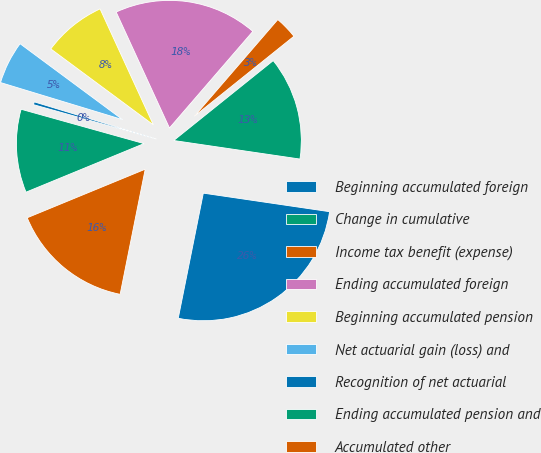<chart> <loc_0><loc_0><loc_500><loc_500><pie_chart><fcel>Beginning accumulated foreign<fcel>Change in cumulative<fcel>Income tax benefit (expense)<fcel>Ending accumulated foreign<fcel>Beginning accumulated pension<fcel>Net actuarial gain (loss) and<fcel>Recognition of net actuarial<fcel>Ending accumulated pension and<fcel>Accumulated other<nl><fcel>25.83%<fcel>13.09%<fcel>2.9%<fcel>18.19%<fcel>8.0%<fcel>5.45%<fcel>0.36%<fcel>10.55%<fcel>15.64%<nl></chart> 